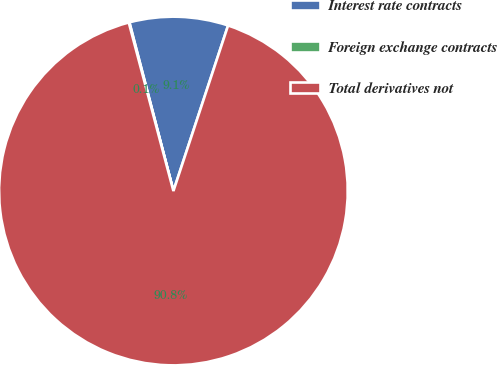Convert chart to OTSL. <chart><loc_0><loc_0><loc_500><loc_500><pie_chart><fcel>Interest rate contracts<fcel>Foreign exchange contracts<fcel>Total derivatives not<nl><fcel>9.14%<fcel>0.06%<fcel>90.8%<nl></chart> 